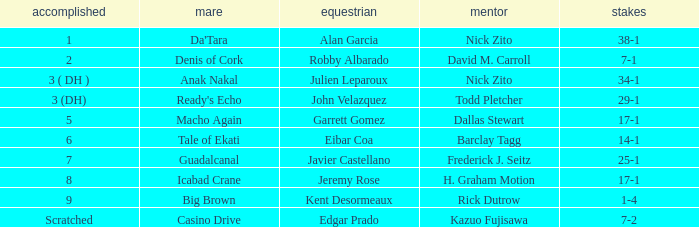What are the Odds for Trainer Barclay Tagg? 14-1. 